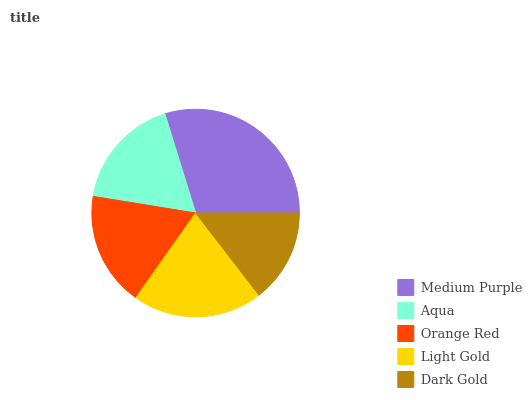Is Dark Gold the minimum?
Answer yes or no. Yes. Is Medium Purple the maximum?
Answer yes or no. Yes. Is Aqua the minimum?
Answer yes or no. No. Is Aqua the maximum?
Answer yes or no. No. Is Medium Purple greater than Aqua?
Answer yes or no. Yes. Is Aqua less than Medium Purple?
Answer yes or no. Yes. Is Aqua greater than Medium Purple?
Answer yes or no. No. Is Medium Purple less than Aqua?
Answer yes or no. No. Is Orange Red the high median?
Answer yes or no. Yes. Is Orange Red the low median?
Answer yes or no. Yes. Is Light Gold the high median?
Answer yes or no. No. Is Dark Gold the low median?
Answer yes or no. No. 